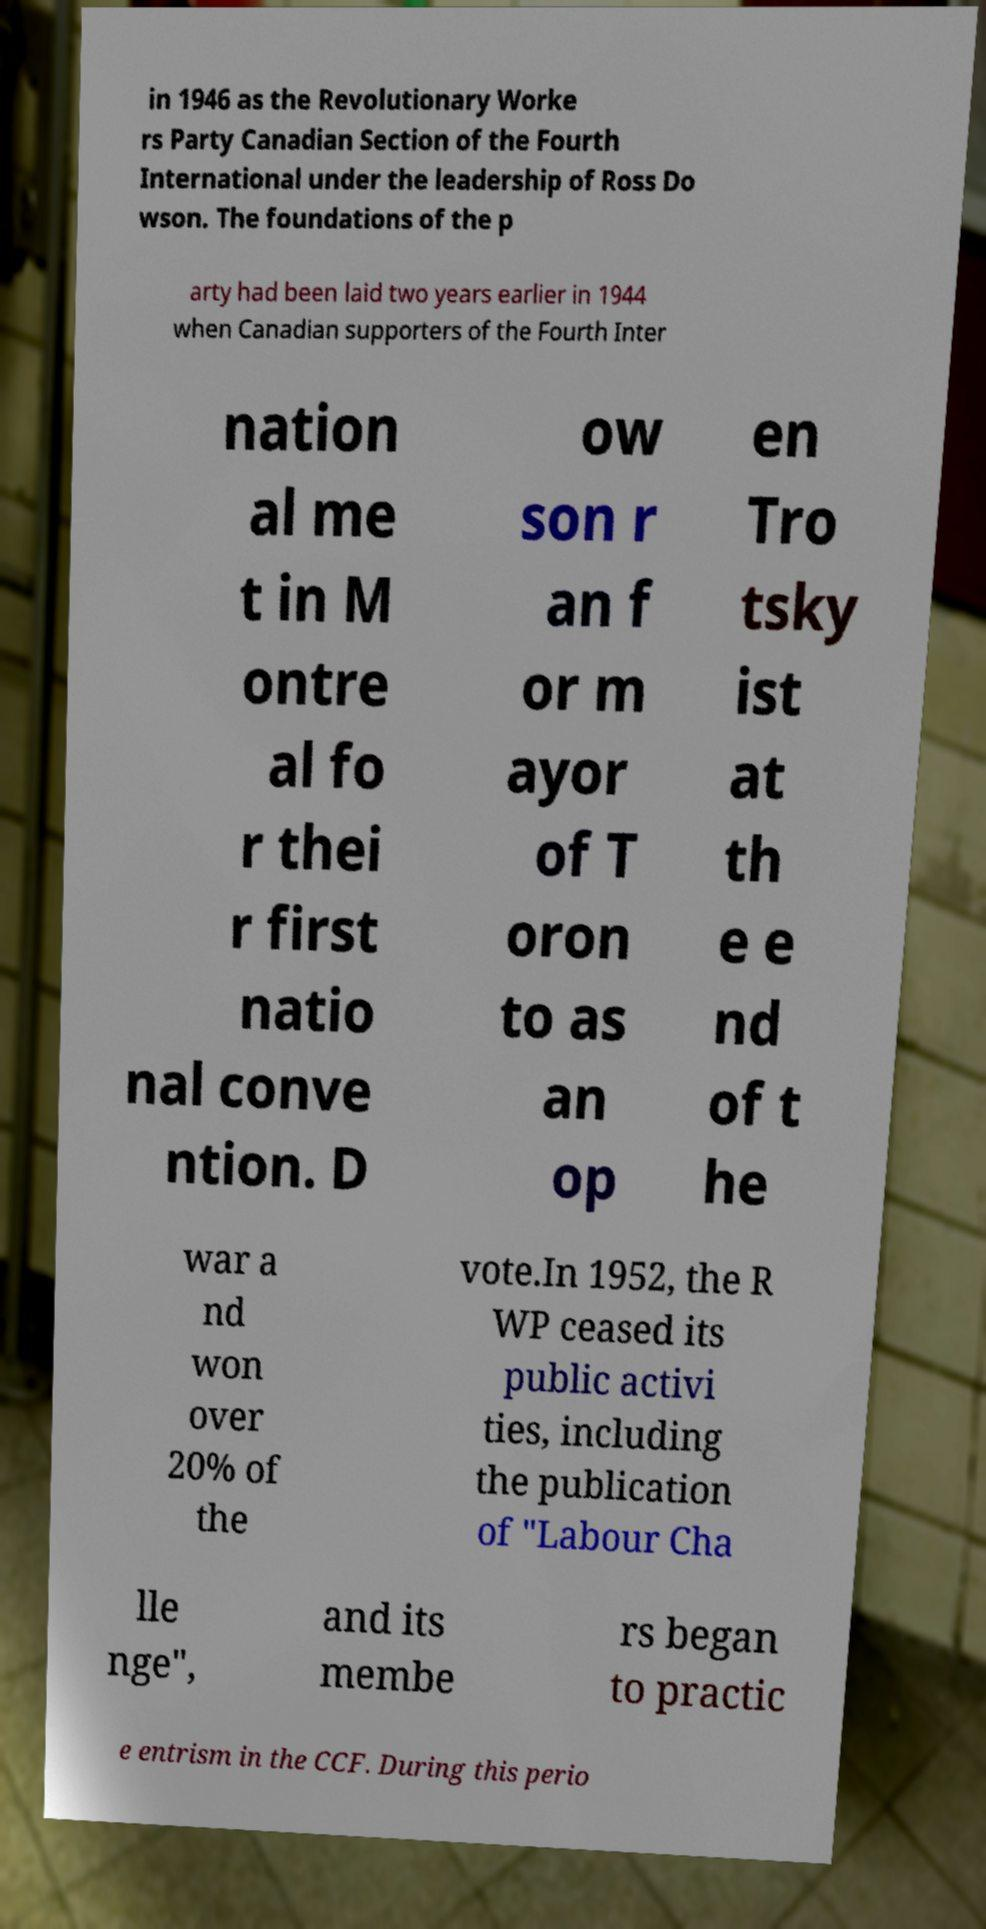Please identify and transcribe the text found in this image. in 1946 as the Revolutionary Worke rs Party Canadian Section of the Fourth International under the leadership of Ross Do wson. The foundations of the p arty had been laid two years earlier in 1944 when Canadian supporters of the Fourth Inter nation al me t in M ontre al fo r thei r first natio nal conve ntion. D ow son r an f or m ayor of T oron to as an op en Tro tsky ist at th e e nd of t he war a nd won over 20% of the vote.In 1952, the R WP ceased its public activi ties, including the publication of "Labour Cha lle nge", and its membe rs began to practic e entrism in the CCF. During this perio 